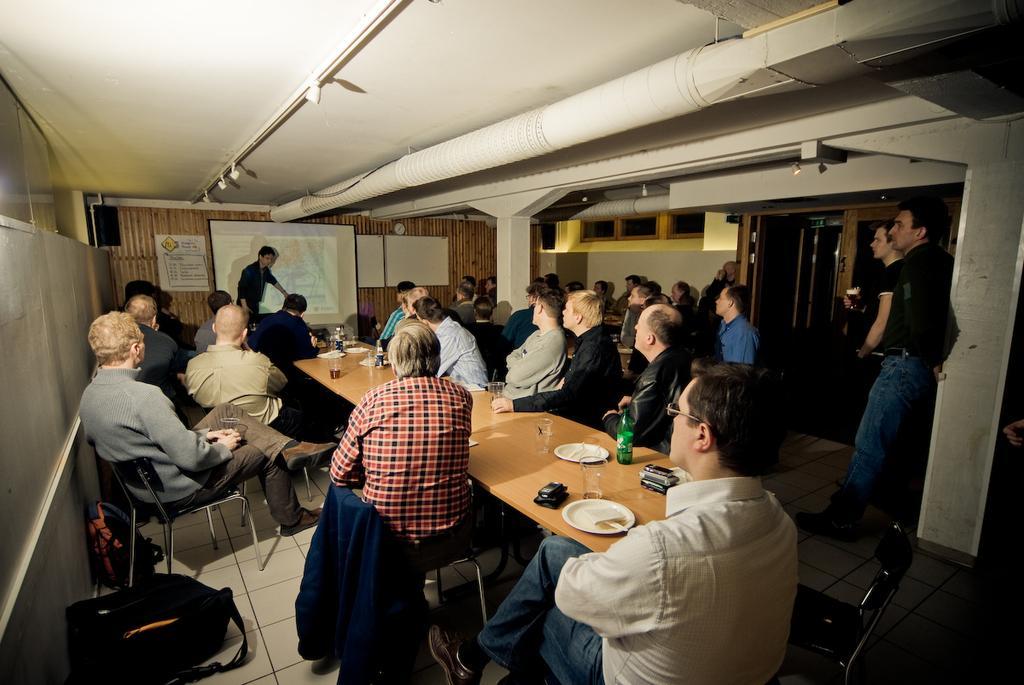Could you give a brief overview of what you see in this image? This picture is of inside. On the right there are two persons standing in which one of them is holding a glass of drink and there is a chair. In the center we can see the group of people sitting on the chairs and there are tables on which plates, bottles, glasses are placed. In the background there is a man standing, a projector screen, wall clock, a poster and a wall and on the left corner there are two bags placed on the ground. 